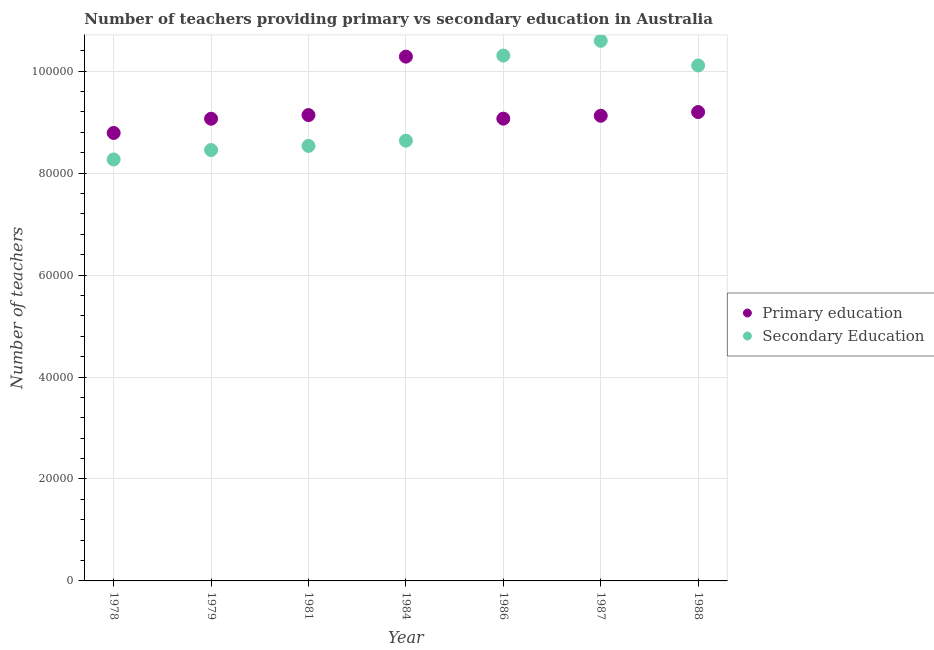Is the number of dotlines equal to the number of legend labels?
Your answer should be compact. Yes. What is the number of secondary teachers in 1984?
Your response must be concise. 8.64e+04. Across all years, what is the maximum number of primary teachers?
Ensure brevity in your answer.  1.03e+05. Across all years, what is the minimum number of primary teachers?
Offer a very short reply. 8.79e+04. In which year was the number of secondary teachers minimum?
Your answer should be very brief. 1978. What is the total number of primary teachers in the graph?
Provide a succinct answer. 6.47e+05. What is the difference between the number of secondary teachers in 1978 and that in 1984?
Give a very brief answer. -3687. What is the difference between the number of secondary teachers in 1987 and the number of primary teachers in 1988?
Keep it short and to the point. 1.40e+04. What is the average number of primary teachers per year?
Give a very brief answer. 9.24e+04. In the year 1987, what is the difference between the number of primary teachers and number of secondary teachers?
Provide a short and direct response. -1.47e+04. In how many years, is the number of secondary teachers greater than 36000?
Make the answer very short. 7. What is the ratio of the number of primary teachers in 1979 to that in 1986?
Provide a short and direct response. 1. Is the number of secondary teachers in 1979 less than that in 1984?
Keep it short and to the point. Yes. Is the difference between the number of secondary teachers in 1981 and 1988 greater than the difference between the number of primary teachers in 1981 and 1988?
Give a very brief answer. No. What is the difference between the highest and the second highest number of secondary teachers?
Provide a short and direct response. 2891. What is the difference between the highest and the lowest number of primary teachers?
Offer a terse response. 1.50e+04. In how many years, is the number of secondary teachers greater than the average number of secondary teachers taken over all years?
Your answer should be very brief. 3. Is the sum of the number of secondary teachers in 1979 and 1986 greater than the maximum number of primary teachers across all years?
Your answer should be compact. Yes. Does the number of secondary teachers monotonically increase over the years?
Make the answer very short. No. Is the number of primary teachers strictly greater than the number of secondary teachers over the years?
Offer a very short reply. No. How many dotlines are there?
Your response must be concise. 2. Are the values on the major ticks of Y-axis written in scientific E-notation?
Your response must be concise. No. Does the graph contain any zero values?
Provide a succinct answer. No. Does the graph contain grids?
Ensure brevity in your answer.  Yes. Where does the legend appear in the graph?
Make the answer very short. Center right. What is the title of the graph?
Your answer should be very brief. Number of teachers providing primary vs secondary education in Australia. Does "Constant 2005 US$" appear as one of the legend labels in the graph?
Give a very brief answer. No. What is the label or title of the Y-axis?
Provide a short and direct response. Number of teachers. What is the Number of teachers of Primary education in 1978?
Give a very brief answer. 8.79e+04. What is the Number of teachers in Secondary Education in 1978?
Offer a terse response. 8.27e+04. What is the Number of teachers of Primary education in 1979?
Ensure brevity in your answer.  9.07e+04. What is the Number of teachers in Secondary Education in 1979?
Keep it short and to the point. 8.45e+04. What is the Number of teachers in Primary education in 1981?
Keep it short and to the point. 9.14e+04. What is the Number of teachers of Secondary Education in 1981?
Provide a succinct answer. 8.53e+04. What is the Number of teachers in Primary education in 1984?
Make the answer very short. 1.03e+05. What is the Number of teachers in Secondary Education in 1984?
Give a very brief answer. 8.64e+04. What is the Number of teachers of Primary education in 1986?
Offer a terse response. 9.07e+04. What is the Number of teachers in Secondary Education in 1986?
Your answer should be compact. 1.03e+05. What is the Number of teachers of Primary education in 1987?
Give a very brief answer. 9.13e+04. What is the Number of teachers of Secondary Education in 1987?
Ensure brevity in your answer.  1.06e+05. What is the Number of teachers of Primary education in 1988?
Give a very brief answer. 9.20e+04. What is the Number of teachers in Secondary Education in 1988?
Provide a short and direct response. 1.01e+05. Across all years, what is the maximum Number of teachers of Primary education?
Provide a succinct answer. 1.03e+05. Across all years, what is the maximum Number of teachers of Secondary Education?
Make the answer very short. 1.06e+05. Across all years, what is the minimum Number of teachers in Primary education?
Keep it short and to the point. 8.79e+04. Across all years, what is the minimum Number of teachers in Secondary Education?
Offer a very short reply. 8.27e+04. What is the total Number of teachers of Primary education in the graph?
Provide a succinct answer. 6.47e+05. What is the total Number of teachers of Secondary Education in the graph?
Keep it short and to the point. 6.49e+05. What is the difference between the Number of teachers in Primary education in 1978 and that in 1979?
Ensure brevity in your answer.  -2790. What is the difference between the Number of teachers of Secondary Education in 1978 and that in 1979?
Your answer should be very brief. -1852. What is the difference between the Number of teachers of Primary education in 1978 and that in 1981?
Offer a very short reply. -3508. What is the difference between the Number of teachers of Secondary Education in 1978 and that in 1981?
Provide a succinct answer. -2663. What is the difference between the Number of teachers in Primary education in 1978 and that in 1984?
Make the answer very short. -1.50e+04. What is the difference between the Number of teachers of Secondary Education in 1978 and that in 1984?
Your answer should be compact. -3687. What is the difference between the Number of teachers in Primary education in 1978 and that in 1986?
Provide a short and direct response. -2807. What is the difference between the Number of teachers of Secondary Education in 1978 and that in 1986?
Offer a very short reply. -2.04e+04. What is the difference between the Number of teachers in Primary education in 1978 and that in 1987?
Your answer should be compact. -3374. What is the difference between the Number of teachers of Secondary Education in 1978 and that in 1987?
Your answer should be very brief. -2.33e+04. What is the difference between the Number of teachers in Primary education in 1978 and that in 1988?
Make the answer very short. -4101. What is the difference between the Number of teachers of Secondary Education in 1978 and that in 1988?
Provide a succinct answer. -1.84e+04. What is the difference between the Number of teachers of Primary education in 1979 and that in 1981?
Provide a succinct answer. -718. What is the difference between the Number of teachers in Secondary Education in 1979 and that in 1981?
Offer a terse response. -811. What is the difference between the Number of teachers of Primary education in 1979 and that in 1984?
Give a very brief answer. -1.22e+04. What is the difference between the Number of teachers of Secondary Education in 1979 and that in 1984?
Your answer should be very brief. -1835. What is the difference between the Number of teachers in Secondary Education in 1979 and that in 1986?
Ensure brevity in your answer.  -1.85e+04. What is the difference between the Number of teachers in Primary education in 1979 and that in 1987?
Offer a very short reply. -584. What is the difference between the Number of teachers of Secondary Education in 1979 and that in 1987?
Give a very brief answer. -2.14e+04. What is the difference between the Number of teachers of Primary education in 1979 and that in 1988?
Keep it short and to the point. -1311. What is the difference between the Number of teachers of Secondary Education in 1979 and that in 1988?
Your answer should be very brief. -1.66e+04. What is the difference between the Number of teachers in Primary education in 1981 and that in 1984?
Your answer should be compact. -1.15e+04. What is the difference between the Number of teachers of Secondary Education in 1981 and that in 1984?
Your answer should be compact. -1024. What is the difference between the Number of teachers of Primary education in 1981 and that in 1986?
Provide a short and direct response. 701. What is the difference between the Number of teachers of Secondary Education in 1981 and that in 1986?
Ensure brevity in your answer.  -1.77e+04. What is the difference between the Number of teachers in Primary education in 1981 and that in 1987?
Your response must be concise. 134. What is the difference between the Number of teachers in Secondary Education in 1981 and that in 1987?
Offer a terse response. -2.06e+04. What is the difference between the Number of teachers of Primary education in 1981 and that in 1988?
Offer a terse response. -593. What is the difference between the Number of teachers of Secondary Education in 1981 and that in 1988?
Give a very brief answer. -1.58e+04. What is the difference between the Number of teachers of Primary education in 1984 and that in 1986?
Make the answer very short. 1.22e+04. What is the difference between the Number of teachers of Secondary Education in 1984 and that in 1986?
Provide a succinct answer. -1.67e+04. What is the difference between the Number of teachers in Primary education in 1984 and that in 1987?
Keep it short and to the point. 1.16e+04. What is the difference between the Number of teachers in Secondary Education in 1984 and that in 1987?
Give a very brief answer. -1.96e+04. What is the difference between the Number of teachers of Primary education in 1984 and that in 1988?
Your answer should be very brief. 1.09e+04. What is the difference between the Number of teachers in Secondary Education in 1984 and that in 1988?
Offer a very short reply. -1.48e+04. What is the difference between the Number of teachers in Primary education in 1986 and that in 1987?
Make the answer very short. -567. What is the difference between the Number of teachers in Secondary Education in 1986 and that in 1987?
Your answer should be very brief. -2891. What is the difference between the Number of teachers of Primary education in 1986 and that in 1988?
Your response must be concise. -1294. What is the difference between the Number of teachers of Secondary Education in 1986 and that in 1988?
Your response must be concise. 1949. What is the difference between the Number of teachers in Primary education in 1987 and that in 1988?
Provide a short and direct response. -727. What is the difference between the Number of teachers of Secondary Education in 1987 and that in 1988?
Provide a short and direct response. 4840. What is the difference between the Number of teachers in Primary education in 1978 and the Number of teachers in Secondary Education in 1979?
Make the answer very short. 3349. What is the difference between the Number of teachers in Primary education in 1978 and the Number of teachers in Secondary Education in 1981?
Offer a terse response. 2538. What is the difference between the Number of teachers of Primary education in 1978 and the Number of teachers of Secondary Education in 1984?
Offer a terse response. 1514. What is the difference between the Number of teachers in Primary education in 1978 and the Number of teachers in Secondary Education in 1986?
Make the answer very short. -1.52e+04. What is the difference between the Number of teachers in Primary education in 1978 and the Number of teachers in Secondary Education in 1987?
Offer a very short reply. -1.81e+04. What is the difference between the Number of teachers in Primary education in 1978 and the Number of teachers in Secondary Education in 1988?
Offer a terse response. -1.32e+04. What is the difference between the Number of teachers of Primary education in 1979 and the Number of teachers of Secondary Education in 1981?
Give a very brief answer. 5328. What is the difference between the Number of teachers in Primary education in 1979 and the Number of teachers in Secondary Education in 1984?
Offer a terse response. 4304. What is the difference between the Number of teachers of Primary education in 1979 and the Number of teachers of Secondary Education in 1986?
Your answer should be compact. -1.24e+04. What is the difference between the Number of teachers of Primary education in 1979 and the Number of teachers of Secondary Education in 1987?
Make the answer very short. -1.53e+04. What is the difference between the Number of teachers of Primary education in 1979 and the Number of teachers of Secondary Education in 1988?
Your answer should be compact. -1.04e+04. What is the difference between the Number of teachers in Primary education in 1981 and the Number of teachers in Secondary Education in 1984?
Ensure brevity in your answer.  5022. What is the difference between the Number of teachers of Primary education in 1981 and the Number of teachers of Secondary Education in 1986?
Provide a succinct answer. -1.17e+04. What is the difference between the Number of teachers of Primary education in 1981 and the Number of teachers of Secondary Education in 1987?
Offer a very short reply. -1.46e+04. What is the difference between the Number of teachers of Primary education in 1981 and the Number of teachers of Secondary Education in 1988?
Provide a succinct answer. -9729. What is the difference between the Number of teachers in Primary education in 1984 and the Number of teachers in Secondary Education in 1986?
Offer a very short reply. -211. What is the difference between the Number of teachers in Primary education in 1984 and the Number of teachers in Secondary Education in 1987?
Give a very brief answer. -3102. What is the difference between the Number of teachers of Primary education in 1984 and the Number of teachers of Secondary Education in 1988?
Offer a very short reply. 1738. What is the difference between the Number of teachers of Primary education in 1986 and the Number of teachers of Secondary Education in 1987?
Your response must be concise. -1.53e+04. What is the difference between the Number of teachers in Primary education in 1986 and the Number of teachers in Secondary Education in 1988?
Give a very brief answer. -1.04e+04. What is the difference between the Number of teachers in Primary education in 1987 and the Number of teachers in Secondary Education in 1988?
Offer a very short reply. -9863. What is the average Number of teachers of Primary education per year?
Provide a succinct answer. 9.24e+04. What is the average Number of teachers of Secondary Education per year?
Offer a very short reply. 9.27e+04. In the year 1978, what is the difference between the Number of teachers in Primary education and Number of teachers in Secondary Education?
Offer a terse response. 5201. In the year 1979, what is the difference between the Number of teachers of Primary education and Number of teachers of Secondary Education?
Your response must be concise. 6139. In the year 1981, what is the difference between the Number of teachers in Primary education and Number of teachers in Secondary Education?
Provide a short and direct response. 6046. In the year 1984, what is the difference between the Number of teachers in Primary education and Number of teachers in Secondary Education?
Offer a terse response. 1.65e+04. In the year 1986, what is the difference between the Number of teachers in Primary education and Number of teachers in Secondary Education?
Offer a terse response. -1.24e+04. In the year 1987, what is the difference between the Number of teachers of Primary education and Number of teachers of Secondary Education?
Make the answer very short. -1.47e+04. In the year 1988, what is the difference between the Number of teachers in Primary education and Number of teachers in Secondary Education?
Your answer should be very brief. -9136. What is the ratio of the Number of teachers in Primary education in 1978 to that in 1979?
Your answer should be compact. 0.97. What is the ratio of the Number of teachers of Secondary Education in 1978 to that in 1979?
Offer a terse response. 0.98. What is the ratio of the Number of teachers in Primary education in 1978 to that in 1981?
Your answer should be very brief. 0.96. What is the ratio of the Number of teachers of Secondary Education in 1978 to that in 1981?
Your answer should be very brief. 0.97. What is the ratio of the Number of teachers of Primary education in 1978 to that in 1984?
Make the answer very short. 0.85. What is the ratio of the Number of teachers in Secondary Education in 1978 to that in 1984?
Make the answer very short. 0.96. What is the ratio of the Number of teachers of Primary education in 1978 to that in 1986?
Provide a short and direct response. 0.97. What is the ratio of the Number of teachers of Secondary Education in 1978 to that in 1986?
Give a very brief answer. 0.8. What is the ratio of the Number of teachers of Secondary Education in 1978 to that in 1987?
Your answer should be compact. 0.78. What is the ratio of the Number of teachers in Primary education in 1978 to that in 1988?
Give a very brief answer. 0.96. What is the ratio of the Number of teachers of Secondary Education in 1978 to that in 1988?
Your answer should be compact. 0.82. What is the ratio of the Number of teachers in Primary education in 1979 to that in 1981?
Your response must be concise. 0.99. What is the ratio of the Number of teachers of Primary education in 1979 to that in 1984?
Ensure brevity in your answer.  0.88. What is the ratio of the Number of teachers in Secondary Education in 1979 to that in 1984?
Offer a very short reply. 0.98. What is the ratio of the Number of teachers in Secondary Education in 1979 to that in 1986?
Keep it short and to the point. 0.82. What is the ratio of the Number of teachers of Secondary Education in 1979 to that in 1987?
Make the answer very short. 0.8. What is the ratio of the Number of teachers of Primary education in 1979 to that in 1988?
Provide a succinct answer. 0.99. What is the ratio of the Number of teachers of Secondary Education in 1979 to that in 1988?
Keep it short and to the point. 0.84. What is the ratio of the Number of teachers of Primary education in 1981 to that in 1984?
Make the answer very short. 0.89. What is the ratio of the Number of teachers of Primary education in 1981 to that in 1986?
Provide a succinct answer. 1.01. What is the ratio of the Number of teachers of Secondary Education in 1981 to that in 1986?
Offer a terse response. 0.83. What is the ratio of the Number of teachers of Primary education in 1981 to that in 1987?
Provide a succinct answer. 1. What is the ratio of the Number of teachers in Secondary Education in 1981 to that in 1987?
Provide a short and direct response. 0.81. What is the ratio of the Number of teachers of Secondary Education in 1981 to that in 1988?
Offer a very short reply. 0.84. What is the ratio of the Number of teachers of Primary education in 1984 to that in 1986?
Your answer should be very brief. 1.13. What is the ratio of the Number of teachers of Secondary Education in 1984 to that in 1986?
Your answer should be compact. 0.84. What is the ratio of the Number of teachers of Primary education in 1984 to that in 1987?
Your response must be concise. 1.13. What is the ratio of the Number of teachers in Secondary Education in 1984 to that in 1987?
Offer a terse response. 0.82. What is the ratio of the Number of teachers in Primary education in 1984 to that in 1988?
Offer a very short reply. 1.12. What is the ratio of the Number of teachers in Secondary Education in 1984 to that in 1988?
Your answer should be very brief. 0.85. What is the ratio of the Number of teachers in Primary education in 1986 to that in 1987?
Provide a succinct answer. 0.99. What is the ratio of the Number of teachers of Secondary Education in 1986 to that in 1987?
Your response must be concise. 0.97. What is the ratio of the Number of teachers of Primary education in 1986 to that in 1988?
Your answer should be compact. 0.99. What is the ratio of the Number of teachers in Secondary Education in 1986 to that in 1988?
Your response must be concise. 1.02. What is the ratio of the Number of teachers in Primary education in 1987 to that in 1988?
Ensure brevity in your answer.  0.99. What is the ratio of the Number of teachers in Secondary Education in 1987 to that in 1988?
Your response must be concise. 1.05. What is the difference between the highest and the second highest Number of teachers of Primary education?
Make the answer very short. 1.09e+04. What is the difference between the highest and the second highest Number of teachers in Secondary Education?
Your response must be concise. 2891. What is the difference between the highest and the lowest Number of teachers in Primary education?
Your answer should be very brief. 1.50e+04. What is the difference between the highest and the lowest Number of teachers in Secondary Education?
Make the answer very short. 2.33e+04. 